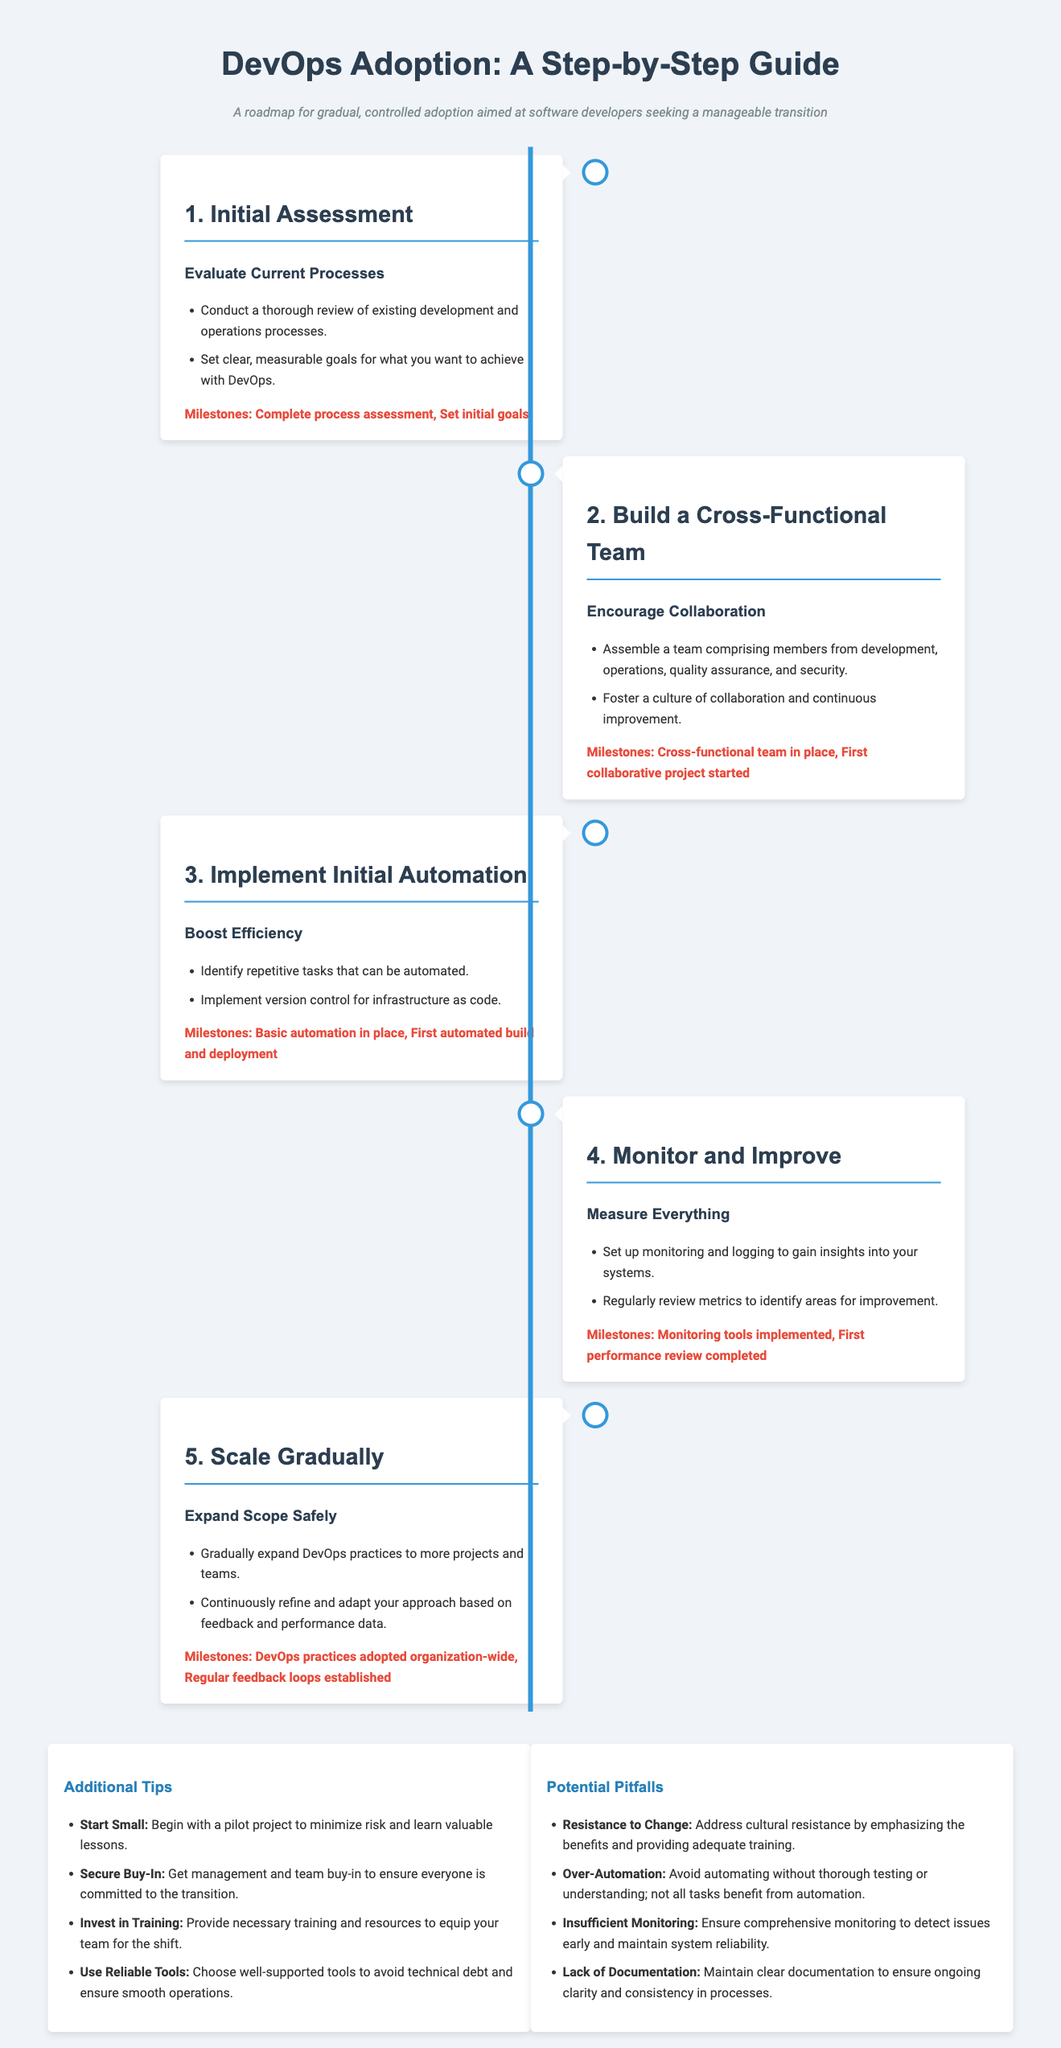What is the first step in the DevOps adoption process? The first step is "Initial Assessment," which involves evaluating current processes.
Answer: Initial Assessment What is a key milestone in building a cross-functional team? A milestone in building a cross-functional team is starting the first collaborative project.
Answer: First collaborative project started How many steps are outlined in the DevOps adoption guide? The guide outlines five steps for adopting DevOps practices.
Answer: Five steps What is one of the additional tips provided for DevOps adoption? One of the additional tips is to "Start Small" by beginning with a pilot project.
Answer: Start Small What potential pitfall emphasizes the need for comprehensive oversight? The pitfall that emphasizes the need for oversight is "Insufficient Monitoring."
Answer: Insufficient Monitoring What should be reviewed to identify areas for improvement? Regularly reviewing "metrics" is recommended to identify areas for improvement.
Answer: Metrics What does the timeline guide illustrate? The timeline illustrates a roadmap for gradual adoption of DevOps practices.
Answer: Roadmap What is the focus of the third step in the process? The focus of the third step is on implementing initial automation to boost efficiency.
Answer: Implement Initial Automation 